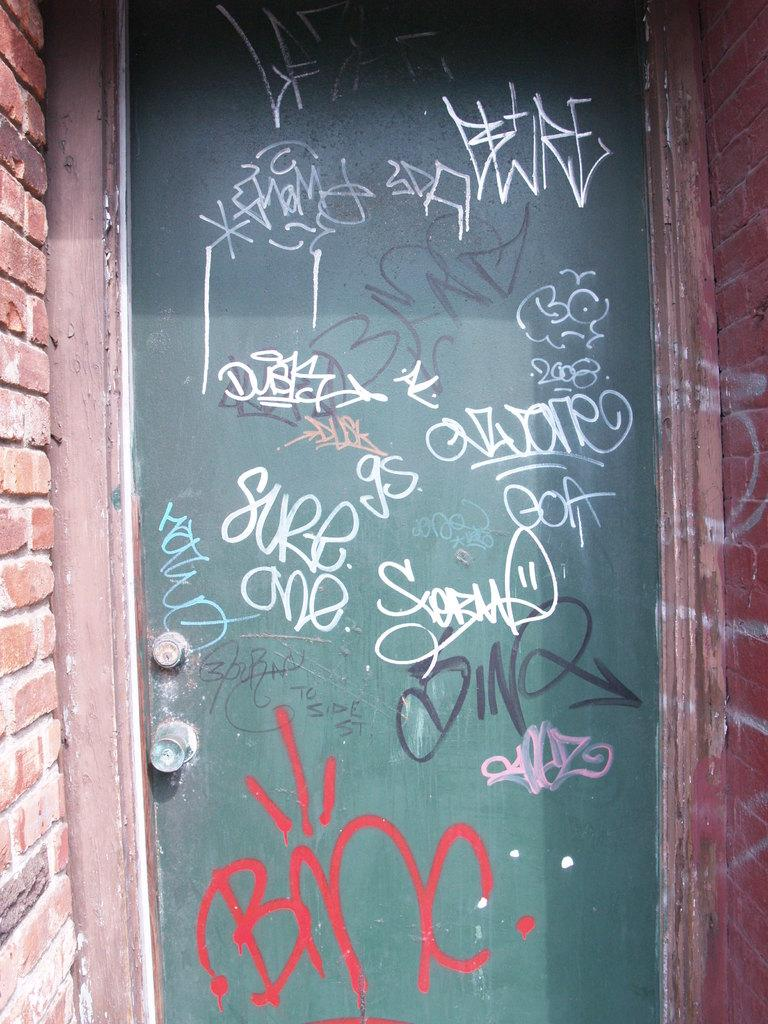What type of structure can be seen in the image? There is a door in the image. What surrounds the door in the image? There are walls in the image. Is there any text or information on the door? Yes, there is writing on the door. What type of clam is crawling on the root in the image? There is no clam or root present in the image. 